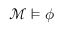<formula> <loc_0><loc_0><loc_500><loc_500>{ \mathcal { M } } \vDash \phi</formula> 